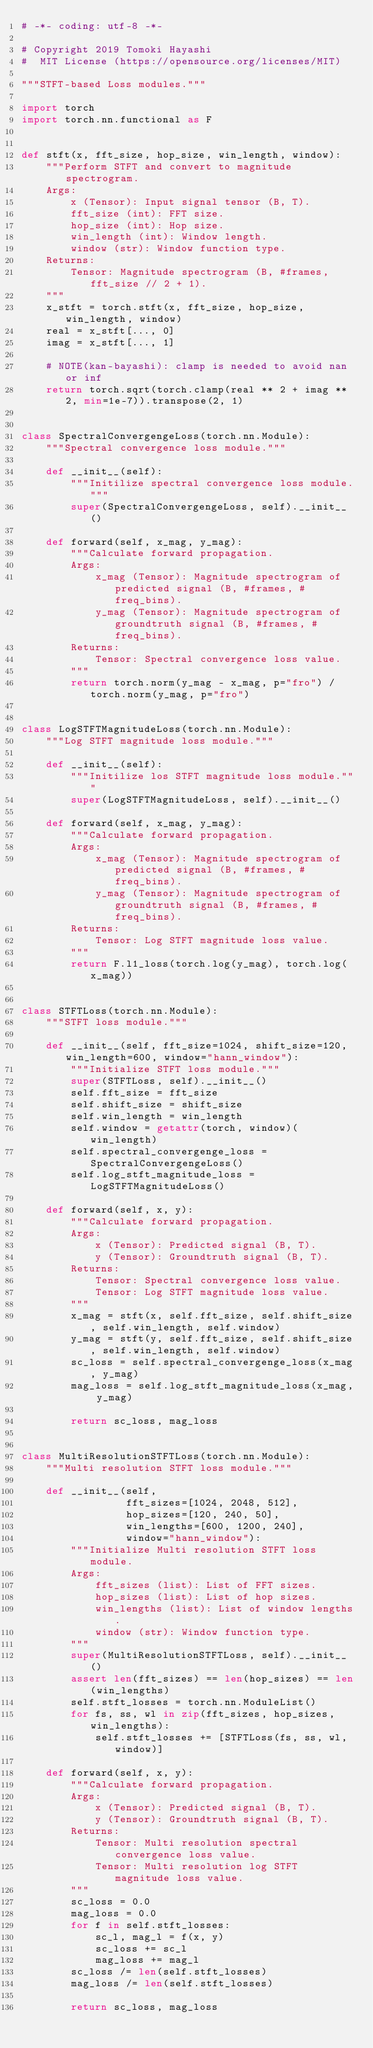<code> <loc_0><loc_0><loc_500><loc_500><_Python_># -*- coding: utf-8 -*-

# Copyright 2019 Tomoki Hayashi
#  MIT License (https://opensource.org/licenses/MIT)

"""STFT-based Loss modules."""

import torch
import torch.nn.functional as F


def stft(x, fft_size, hop_size, win_length, window):
    """Perform STFT and convert to magnitude spectrogram.
    Args:
        x (Tensor): Input signal tensor (B, T).
        fft_size (int): FFT size.
        hop_size (int): Hop size.
        win_length (int): Window length.
        window (str): Window function type.
    Returns:
        Tensor: Magnitude spectrogram (B, #frames, fft_size // 2 + 1).
    """
    x_stft = torch.stft(x, fft_size, hop_size, win_length, window)
    real = x_stft[..., 0]
    imag = x_stft[..., 1]

    # NOTE(kan-bayashi): clamp is needed to avoid nan or inf
    return torch.sqrt(torch.clamp(real ** 2 + imag ** 2, min=1e-7)).transpose(2, 1)


class SpectralConvergengeLoss(torch.nn.Module):
    """Spectral convergence loss module."""

    def __init__(self):
        """Initilize spectral convergence loss module."""
        super(SpectralConvergengeLoss, self).__init__()

    def forward(self, x_mag, y_mag):
        """Calculate forward propagation.
        Args:
            x_mag (Tensor): Magnitude spectrogram of predicted signal (B, #frames, #freq_bins).
            y_mag (Tensor): Magnitude spectrogram of groundtruth signal (B, #frames, #freq_bins).
        Returns:
            Tensor: Spectral convergence loss value.
        """
        return torch.norm(y_mag - x_mag, p="fro") / torch.norm(y_mag, p="fro")


class LogSTFTMagnitudeLoss(torch.nn.Module):
    """Log STFT magnitude loss module."""

    def __init__(self):
        """Initilize los STFT magnitude loss module."""
        super(LogSTFTMagnitudeLoss, self).__init__()

    def forward(self, x_mag, y_mag):
        """Calculate forward propagation.
        Args:
            x_mag (Tensor): Magnitude spectrogram of predicted signal (B, #frames, #freq_bins).
            y_mag (Tensor): Magnitude spectrogram of groundtruth signal (B, #frames, #freq_bins).
        Returns:
            Tensor: Log STFT magnitude loss value.
        """
        return F.l1_loss(torch.log(y_mag), torch.log(x_mag))


class STFTLoss(torch.nn.Module):
    """STFT loss module."""

    def __init__(self, fft_size=1024, shift_size=120, win_length=600, window="hann_window"):
        """Initialize STFT loss module."""
        super(STFTLoss, self).__init__()
        self.fft_size = fft_size
        self.shift_size = shift_size
        self.win_length = win_length
        self.window = getattr(torch, window)(win_length)
        self.spectral_convergenge_loss = SpectralConvergengeLoss()
        self.log_stft_magnitude_loss = LogSTFTMagnitudeLoss()

    def forward(self, x, y):
        """Calculate forward propagation.
        Args:
            x (Tensor): Predicted signal (B, T).
            y (Tensor): Groundtruth signal (B, T).
        Returns:
            Tensor: Spectral convergence loss value.
            Tensor: Log STFT magnitude loss value.
        """
        x_mag = stft(x, self.fft_size, self.shift_size, self.win_length, self.window)
        y_mag = stft(y, self.fft_size, self.shift_size, self.win_length, self.window)
        sc_loss = self.spectral_convergenge_loss(x_mag, y_mag)
        mag_loss = self.log_stft_magnitude_loss(x_mag, y_mag)

        return sc_loss, mag_loss


class MultiResolutionSTFTLoss(torch.nn.Module):
    """Multi resolution STFT loss module."""

    def __init__(self,
                 fft_sizes=[1024, 2048, 512],
                 hop_sizes=[120, 240, 50],
                 win_lengths=[600, 1200, 240],
                 window="hann_window"):
        """Initialize Multi resolution STFT loss module.
        Args:
            fft_sizes (list): List of FFT sizes.
            hop_sizes (list): List of hop sizes.
            win_lengths (list): List of window lengths.
            window (str): Window function type.
        """
        super(MultiResolutionSTFTLoss, self).__init__()
        assert len(fft_sizes) == len(hop_sizes) == len(win_lengths)
        self.stft_losses = torch.nn.ModuleList()
        for fs, ss, wl in zip(fft_sizes, hop_sizes, win_lengths):
            self.stft_losses += [STFTLoss(fs, ss, wl, window)]

    def forward(self, x, y):
        """Calculate forward propagation.
        Args:
            x (Tensor): Predicted signal (B, T).
            y (Tensor): Groundtruth signal (B, T).
        Returns:
            Tensor: Multi resolution spectral convergence loss value.
            Tensor: Multi resolution log STFT magnitude loss value.
        """
        sc_loss = 0.0
        mag_loss = 0.0
        for f in self.stft_losses:
            sc_l, mag_l = f(x, y)
            sc_loss += sc_l
            mag_loss += mag_l
        sc_loss /= len(self.stft_losses)
        mag_loss /= len(self.stft_losses)

        return sc_loss, mag_loss</code> 